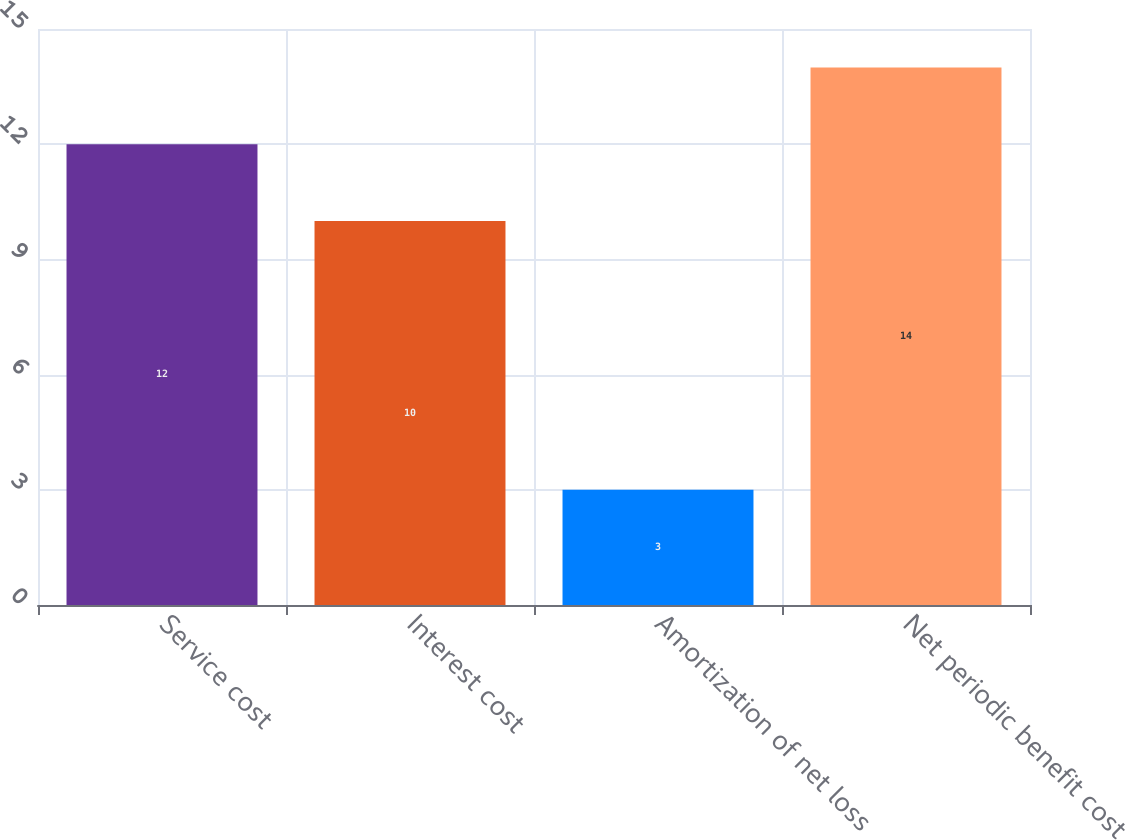Convert chart. <chart><loc_0><loc_0><loc_500><loc_500><bar_chart><fcel>Service cost<fcel>Interest cost<fcel>Amortization of net loss<fcel>Net periodic benefit cost<nl><fcel>12<fcel>10<fcel>3<fcel>14<nl></chart> 